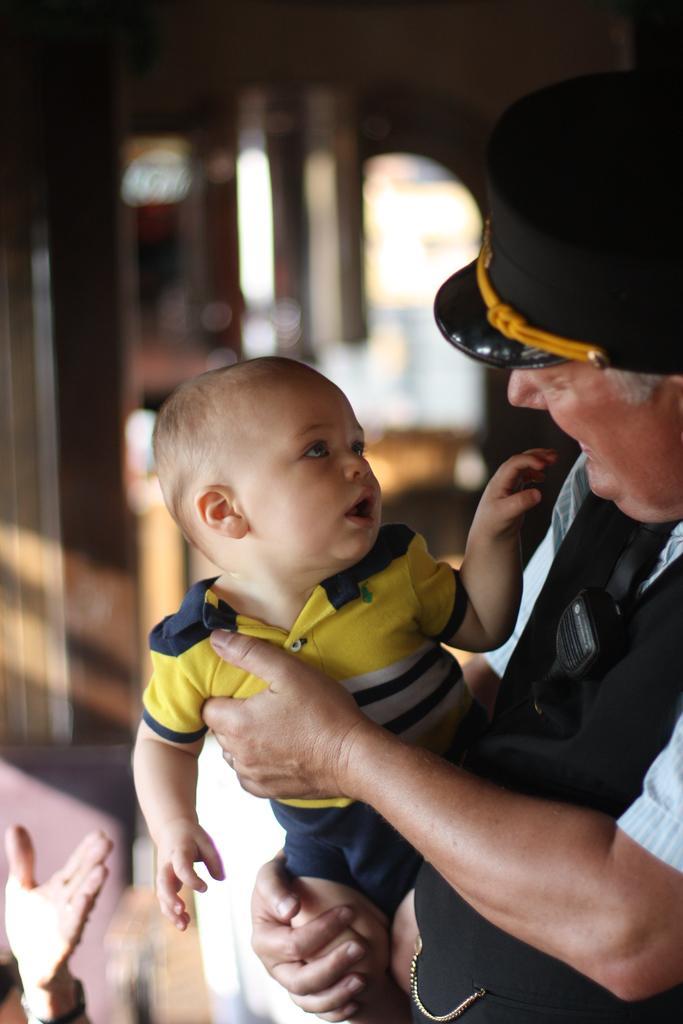Describe this image in one or two sentences. In this picture we can observe a person wearing black color T shirt and a cap on his head. He is holding a baby in his hands. The baby is wearing yellow color T shirt. We can observe a hand on the left side. The background is completely blurred. 